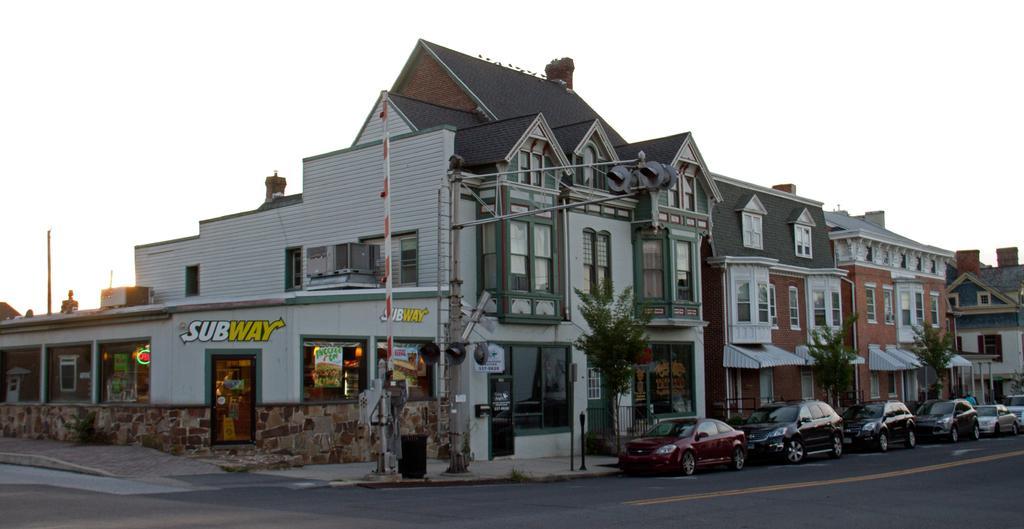Can you describe this image briefly? In this image we can see cars on the road on the right side. In the background there are trees, fence, buildings, windows, trees, doors, curtains, roofs, poles, posters on the glass doors and sky. 